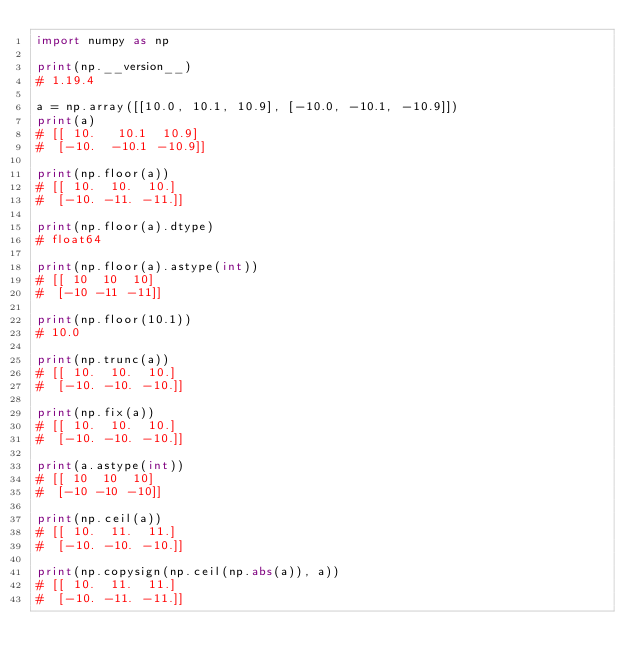<code> <loc_0><loc_0><loc_500><loc_500><_Python_>import numpy as np

print(np.__version__)
# 1.19.4

a = np.array([[10.0, 10.1, 10.9], [-10.0, -10.1, -10.9]])
print(a)
# [[ 10.   10.1  10.9]
#  [-10.  -10.1 -10.9]]

print(np.floor(a))
# [[ 10.  10.  10.]
#  [-10. -11. -11.]]

print(np.floor(a).dtype)
# float64

print(np.floor(a).astype(int))
# [[ 10  10  10]
#  [-10 -11 -11]]

print(np.floor(10.1))
# 10.0

print(np.trunc(a))
# [[ 10.  10.  10.]
#  [-10. -10. -10.]]

print(np.fix(a))
# [[ 10.  10.  10.]
#  [-10. -10. -10.]]

print(a.astype(int))
# [[ 10  10  10]
#  [-10 -10 -10]]

print(np.ceil(a))
# [[ 10.  11.  11.]
#  [-10. -10. -10.]]

print(np.copysign(np.ceil(np.abs(a)), a))
# [[ 10.  11.  11.]
#  [-10. -11. -11.]]
</code> 